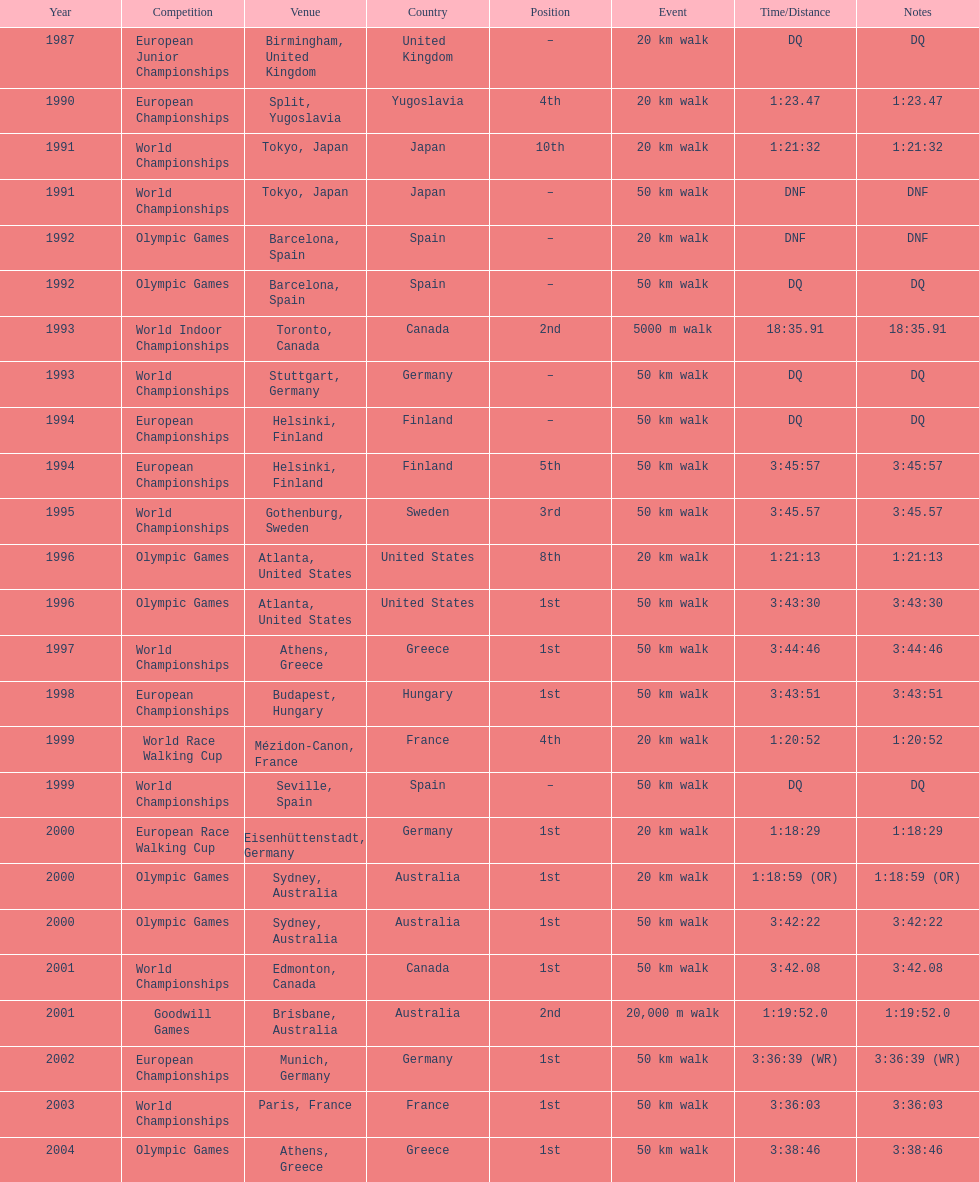Which of the competitions were 50 km walks? World Championships, Olympic Games, World Championships, European Championships, European Championships, World Championships, Olympic Games, World Championships, European Championships, World Championships, Olympic Games, World Championships, European Championships, World Championships, Olympic Games. Of these, which took place during or after the year 2000? Olympic Games, World Championships, European Championships, World Championships, Olympic Games. From these, which took place in athens, greece? Olympic Games. What was the time to finish for this competition? 3:38:46. 